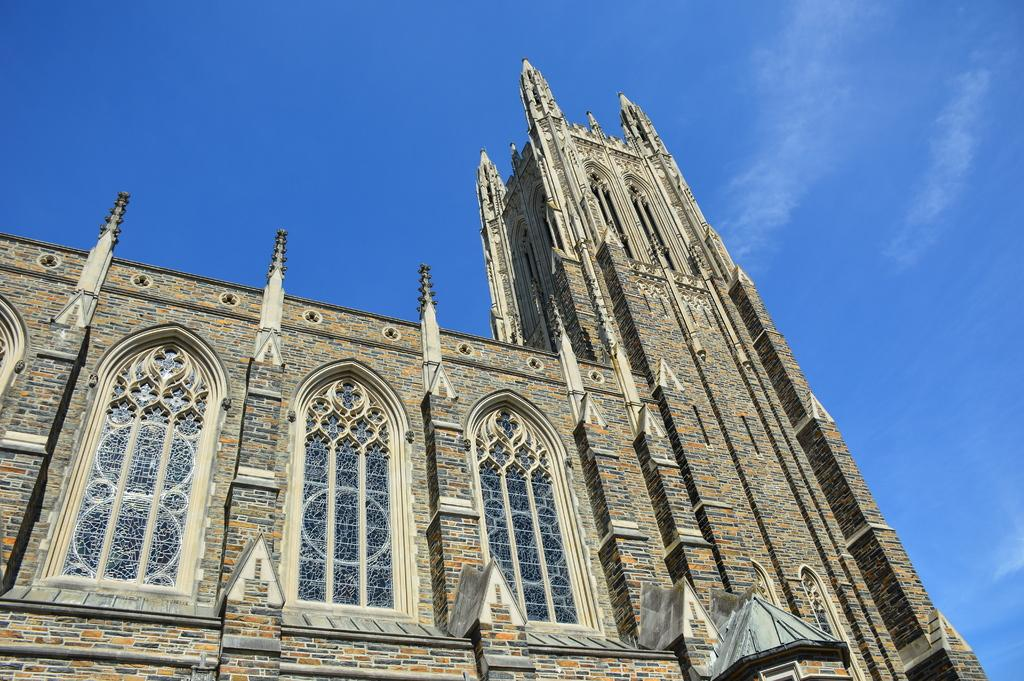What is the main structure in the picture? There is a building in the picture. How would you describe the sky in the image? The sky is blue and cloudy. What type of crack can be seen in the building's foundation in the image? There is no crack visible in the building's foundation in the image. What mineral, such as quartz, can be seen in the building's construction in the image? There is no mention of any specific minerals, such as quartz, being visible in the building's construction in the image. 